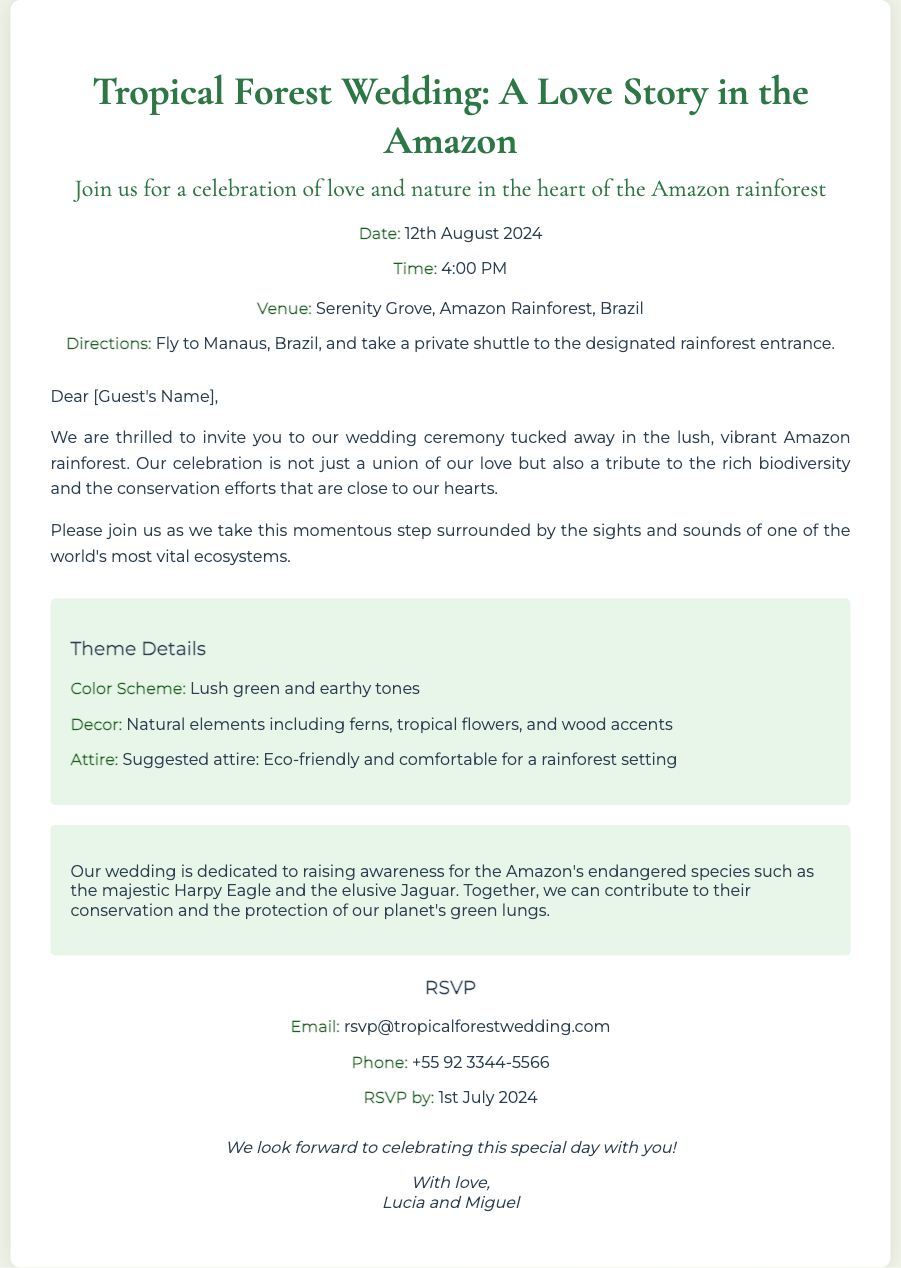What is the date of the wedding? The wedding is scheduled for the date mentioned in the document, which states "12th August 2024."
Answer: 12th August 2024 What time will the ceremony begin? The time for the wedding ceremony is listed in the document as "4:00 PM."
Answer: 4:00 PM Where is the wedding venue located? The venue is described in the document as "Serenity Grove, Amazon Rainforest, Brazil."
Answer: Serenity Grove, Amazon Rainforest, Brazil What color scheme is suggested for the wedding? The color scheme is highlighted in the document, stating "Lush green and earthy tones."
Answer: Lush green and earthy tones Who are the hosts of the wedding? The document reveals the names of the hosts as "Lucia and Miguel."
Answer: Lucia and Miguel What conservation message is included in the invitation? The document emphasizes raising awareness for endangered species, mentioning "the majestic Harpy Eagle and the elusive Jaguar."
Answer: the majestic Harpy Eagle and the elusive Jaguar When is the RSVP deadline? The RSVP deadline is specified in the document as "1st July 2024."
Answer: 1st July 2024 What type of attire is suggested for the guests? Suggested attire is discussed in the document and states "Eco-friendly and comfortable for a rainforest setting."
Answer: Eco-friendly and comfortable for a rainforest setting What means of transportation is recommended to reach the venue? The document suggests that guests "Fly to Manaus, Brazil, and take a private shuttle."
Answer: Fly to Manaus, Brazil, and take a private shuttle 